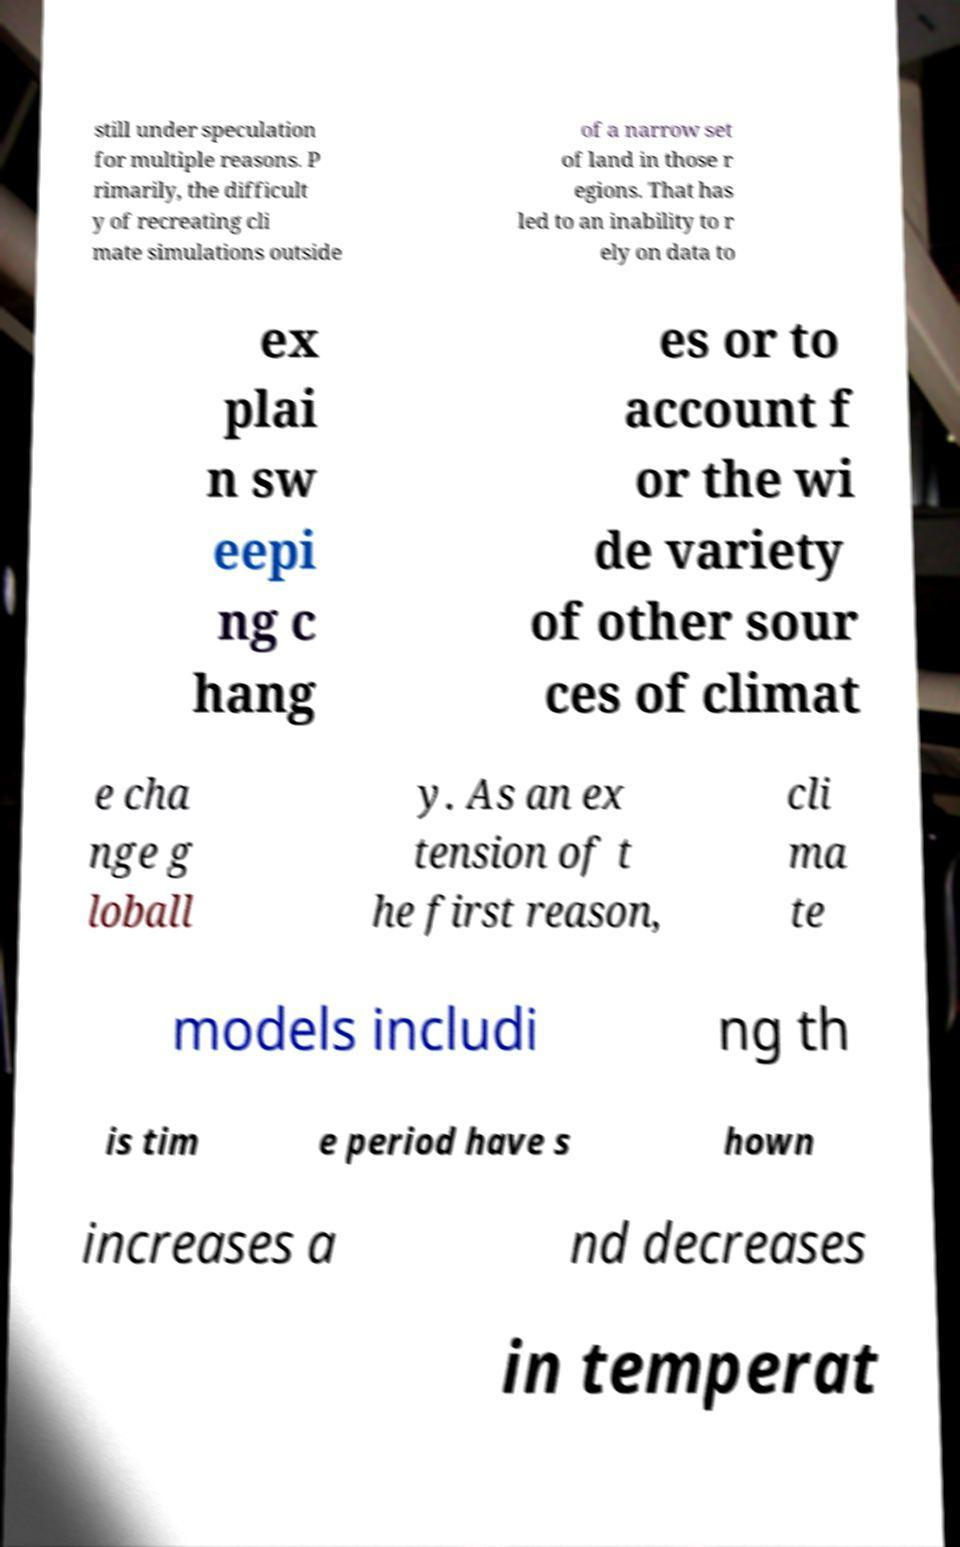What messages or text are displayed in this image? I need them in a readable, typed format. still under speculation for multiple reasons. P rimarily, the difficult y of recreating cli mate simulations outside of a narrow set of land in those r egions. That has led to an inability to r ely on data to ex plai n sw eepi ng c hang es or to account f or the wi de variety of other sour ces of climat e cha nge g loball y. As an ex tension of t he first reason, cli ma te models includi ng th is tim e period have s hown increases a nd decreases in temperat 